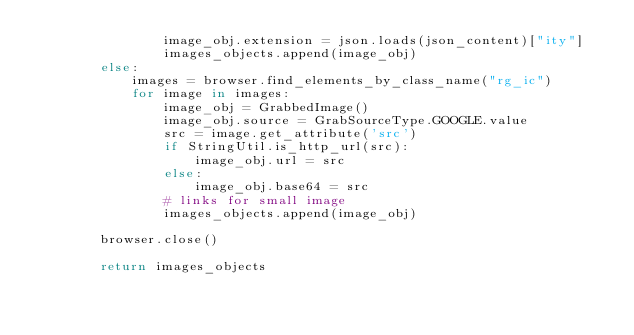<code> <loc_0><loc_0><loc_500><loc_500><_Python_>                image_obj.extension = json.loads(json_content)["ity"]
                images_objects.append(image_obj)
        else:
            images = browser.find_elements_by_class_name("rg_ic")
            for image in images:
                image_obj = GrabbedImage()
                image_obj.source = GrabSourceType.GOOGLE.value
                src = image.get_attribute('src')
                if StringUtil.is_http_url(src):
                    image_obj.url = src
                else:
                    image_obj.base64 = src
                # links for small image
                images_objects.append(image_obj)

        browser.close()

        return images_objects
</code> 